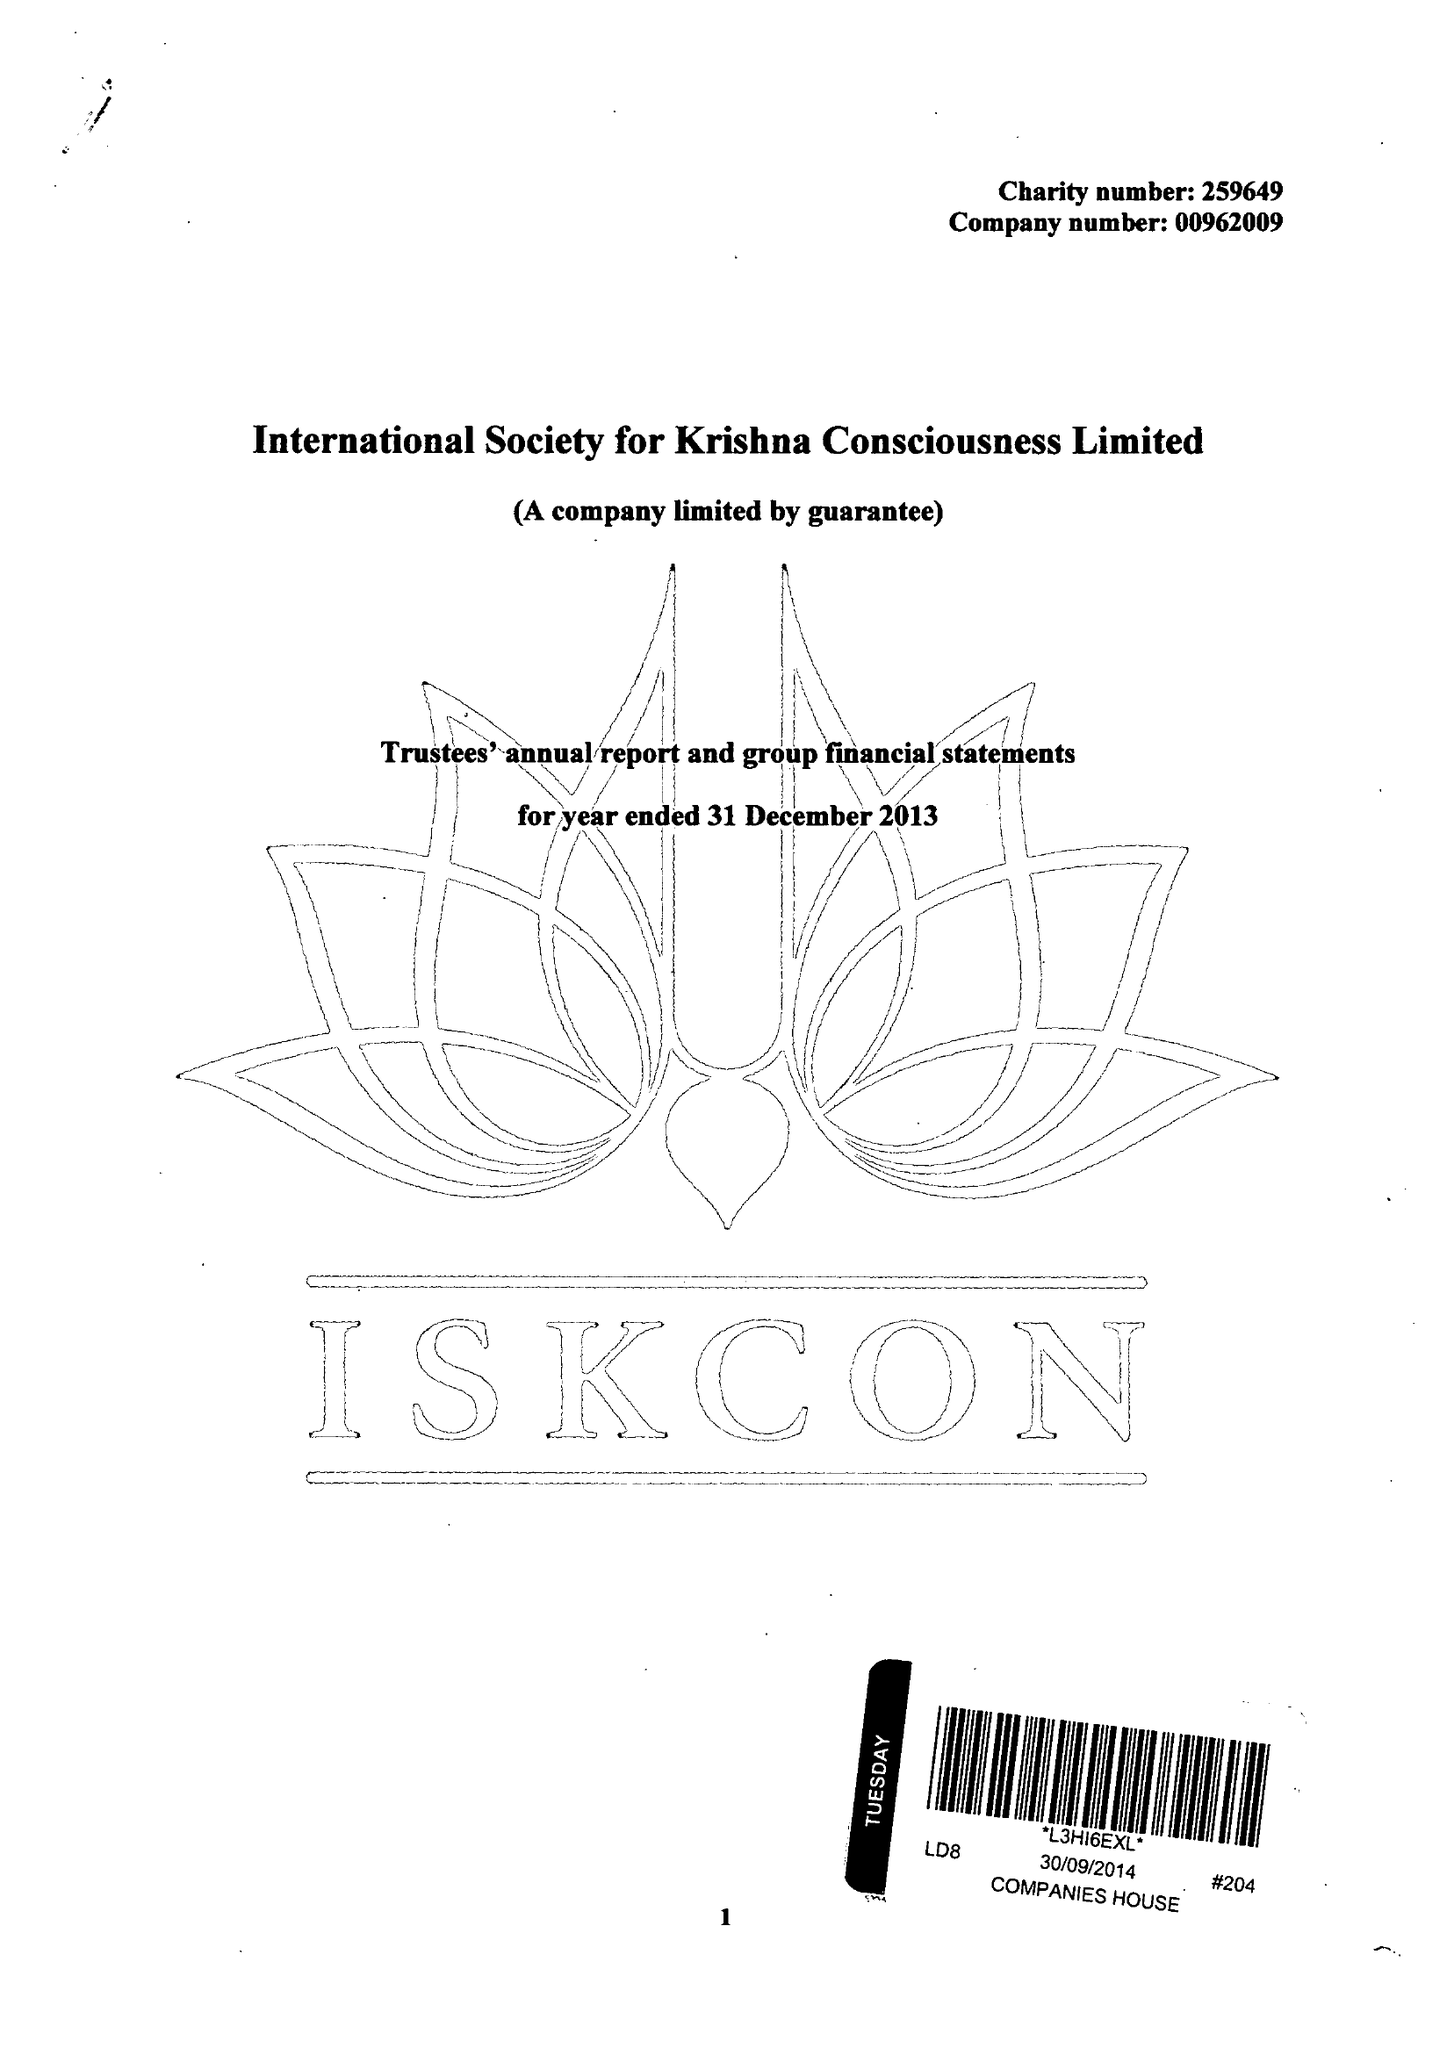What is the value for the address__street_line?
Answer the question using a single word or phrase. 1 WATFORD ROAD 